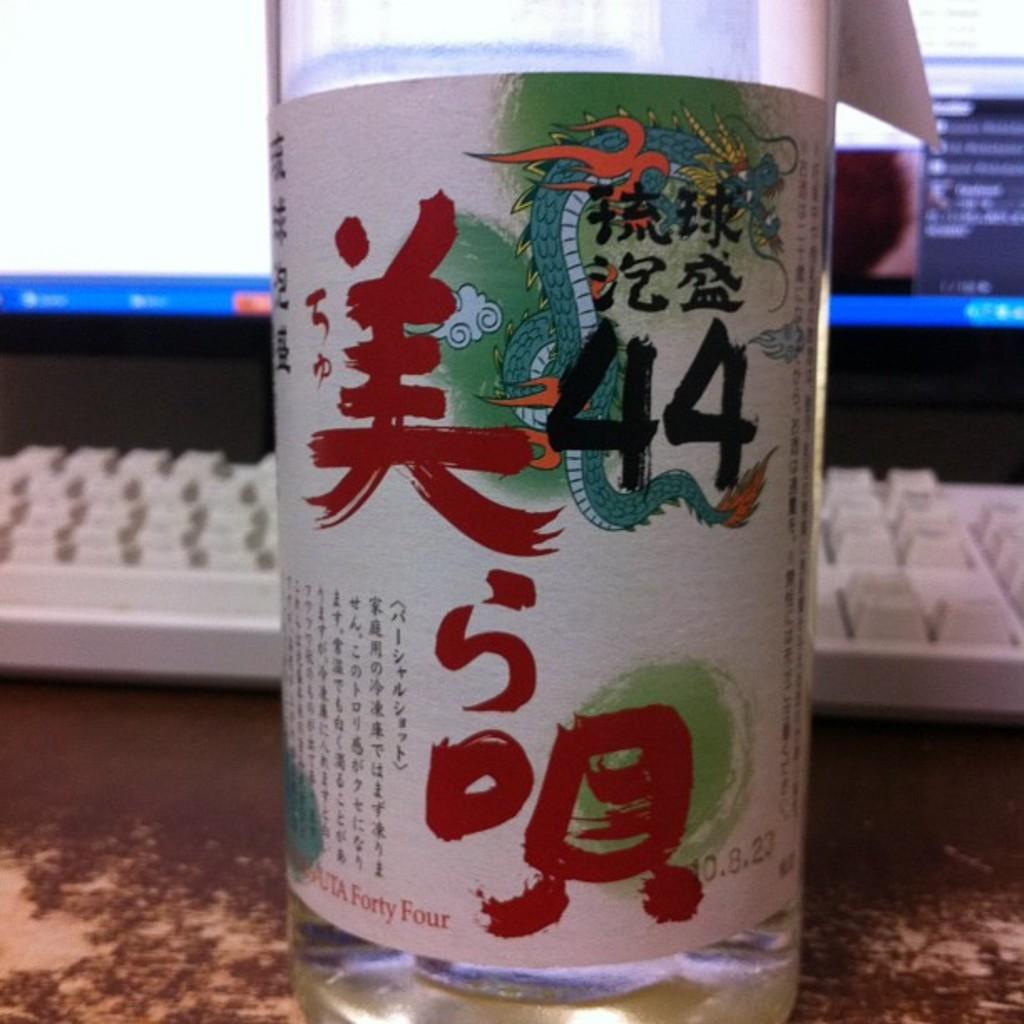How many ounces is the beverage?
Give a very brief answer. Unanswerable. 